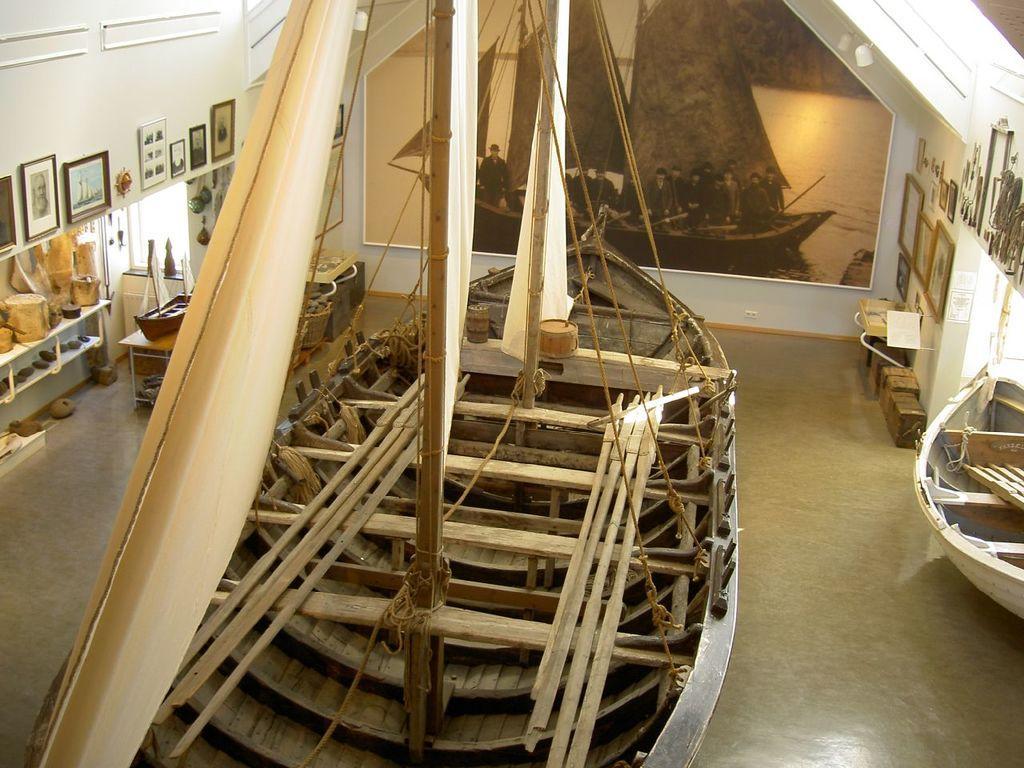Can you describe this image briefly? On the floor there is a boat. We can see wooden sticks on the boat and we can see ropes tied to the bed. In the background there are frames on the wall. On the left there are wood pieces on a stand and there is a big photo frame on the wall. On the right there is a small boat on the floor and we can also some other items in the room. 